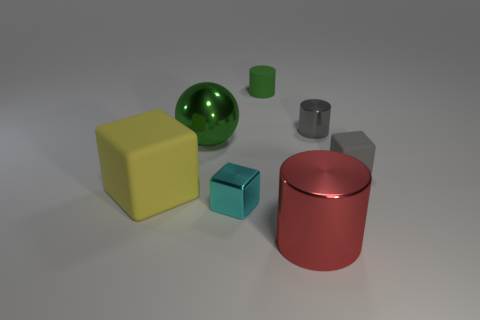Add 1 large gray things. How many objects exist? 8 Subtract all tiny blocks. How many blocks are left? 1 Subtract 1 gray cylinders. How many objects are left? 6 Subtract all balls. How many objects are left? 6 Subtract 2 blocks. How many blocks are left? 1 Subtract all purple spheres. Subtract all cyan cylinders. How many spheres are left? 1 Subtract all blue cylinders. How many gray spheres are left? 0 Subtract all small cyan cubes. Subtract all large red shiny cylinders. How many objects are left? 5 Add 1 small gray objects. How many small gray objects are left? 3 Add 1 green matte objects. How many green matte objects exist? 2 